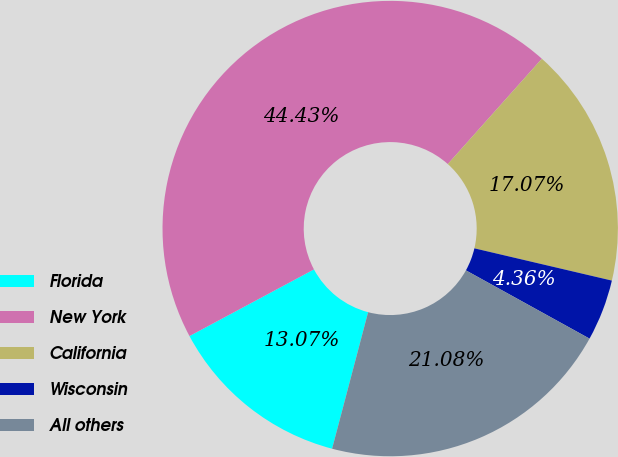Convert chart to OTSL. <chart><loc_0><loc_0><loc_500><loc_500><pie_chart><fcel>Florida<fcel>New York<fcel>California<fcel>Wisconsin<fcel>All others<nl><fcel>13.07%<fcel>44.43%<fcel>17.07%<fcel>4.36%<fcel>21.08%<nl></chart> 